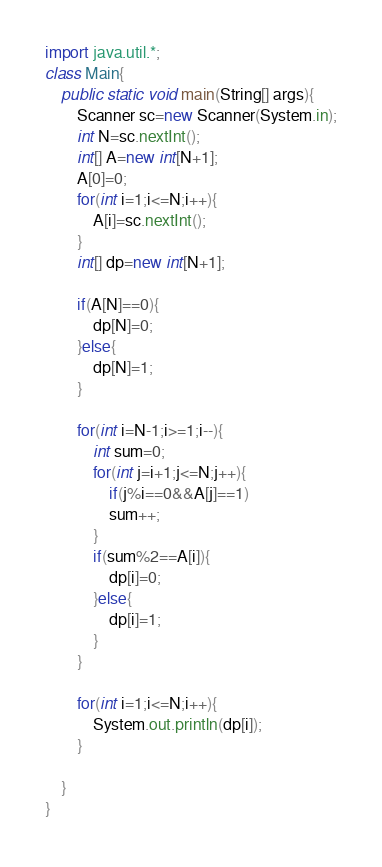Convert code to text. <code><loc_0><loc_0><loc_500><loc_500><_Java_>import java.util.*;
class Main{
	public static void main(String[] args){
		Scanner sc=new Scanner(System.in);
		int N=sc.nextInt();
		int[] A=new int[N+1];
		A[0]=0;
		for(int i=1;i<=N;i++){
			A[i]=sc.nextInt();
		}
		int[] dp=new int[N+1];
		
		if(A[N]==0){
			dp[N]=0;
		}else{
			dp[N]=1;
		}
		
		for(int i=N-1;i>=1;i--){
			int sum=0;
			for(int j=i+1;j<=N;j++){
				if(j%i==0&&A[j]==1)
				sum++;
			}
			if(sum%2==A[i]){
				dp[i]=0;
			}else{
				dp[i]=1;
			}
		}
		
		for(int i=1;i<=N;i++){
			System.out.println(dp[i]);
		}
		
	}
}	</code> 